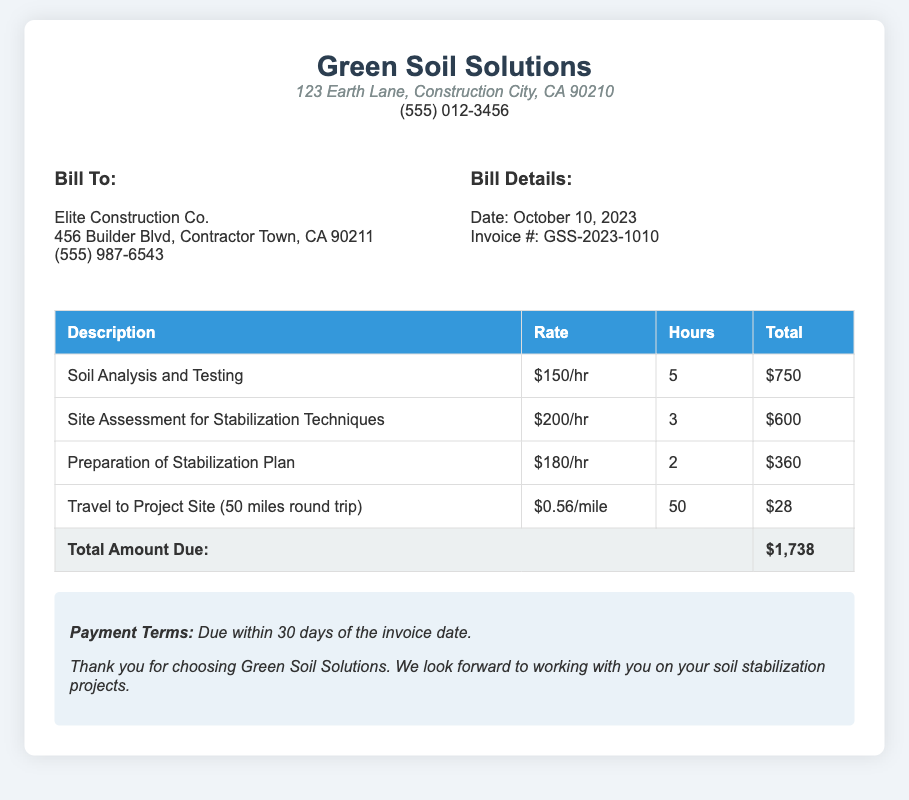What is the date of the invoice? The date of the invoice is mentioned in the bill details section.
Answer: October 10, 2023 What is the total amount due? The total amount due is indicated in the total row of the table.
Answer: $1,738 Who is the billing address for? The billing address is stated clearly at the beginning of the bill.
Answer: Elite Construction Co How much is charged for soil analysis and testing? The charge for soil analysis and testing is provided in the description with the hourly rate and hours worked.
Answer: $750 What is the rate for site assessment for stabilization techniques? The rate can be found in the table under the description for site assessment.
Answer: $200/hr How many hours were worked for the preparation of the stabilization plan? The number of hours worked is listed next to the description in the table.
Answer: 2 What is the cost per mile for travel to the project site? The cost per mile is specified in the travel description row within the table.
Answer: $0.56/mile What are the payment terms? The payment terms are stated at the bottom of the bill.
Answer: Due within 30 days of the invoice date What is the description for the last line item in the bill? The last line item refers to travel expenses, which is detailed in the table.
Answer: Travel to Project Site (50 miles round trip) 